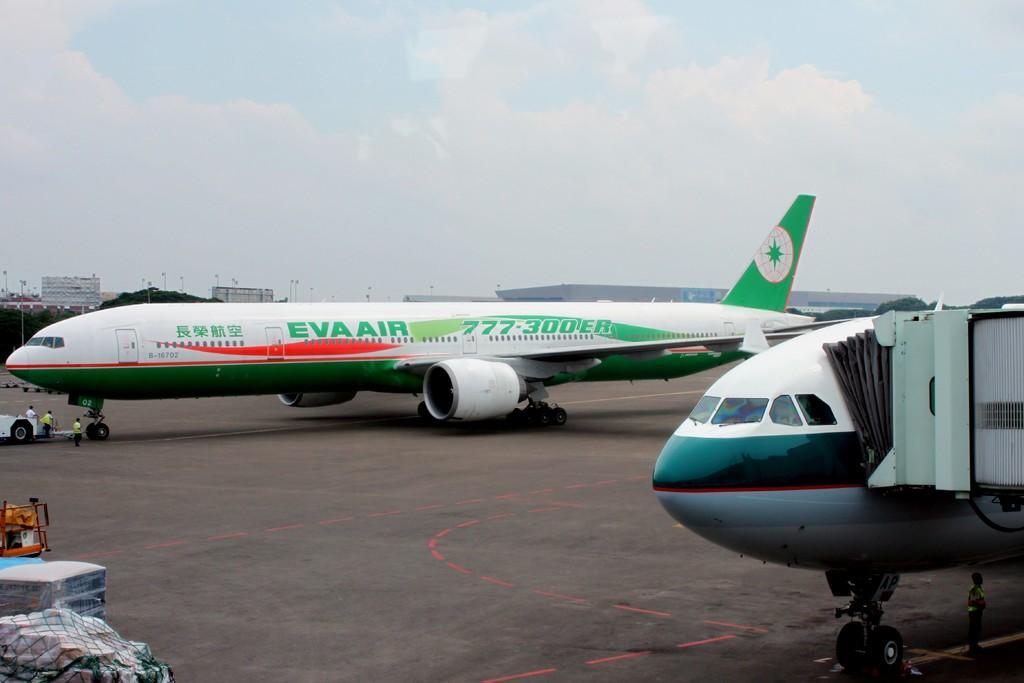Could you give a brief overview of what you see in this image? In the image there are two aeroplanes on the road and behind it there are buildings and above its sky with clouds. 